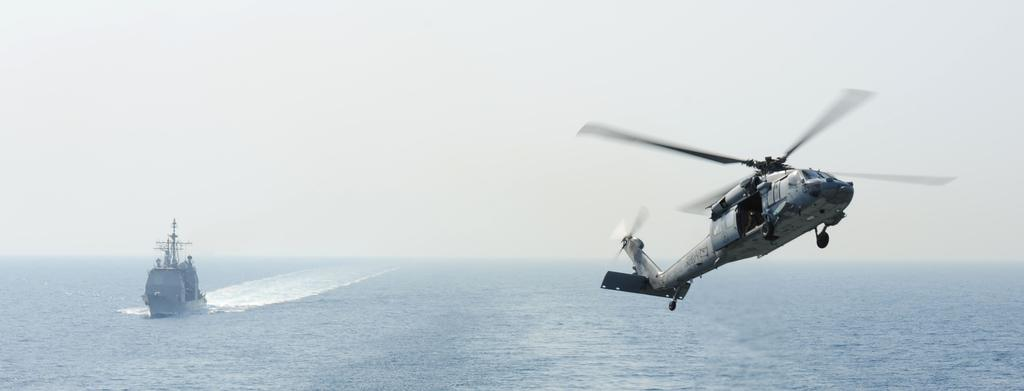What is the main subject of the image? The main subject of the image is a ship. What is the ship doing in the image? The ship is sailing in water. What other mode of transportation can be seen in the image? There is a helicopter in the image, and it is flying in the air. What is visible at the top of the image? The sky is visible at the top of the image. Where is the kitty hiding under the ship in the image? There is no kitty present in the image, so it cannot be hiding under the ship. 